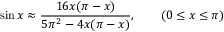<formula> <loc_0><loc_0><loc_500><loc_500>\sin x \approx { \frac { 1 6 x ( \pi - x ) } { 5 \pi ^ { 2 } - 4 x ( \pi - x ) } } , \quad ( 0 \leq x \leq \pi )</formula> 